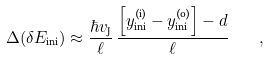Convert formula to latex. <formula><loc_0><loc_0><loc_500><loc_500>\Delta ( \delta E _ { \text {ini} } ) \approx \frac { \hbar { v } _ { \text {J} } } { \ell } \, \frac { \left [ y ^ { \text {(i)} } _ { \text {ini} } - y ^ { \text {(o)} } _ { \text {ini} } \right ] - d } { \ell } \quad ,</formula> 